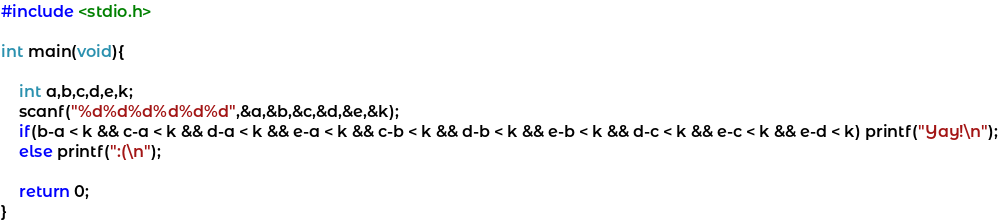Convert code to text. <code><loc_0><loc_0><loc_500><loc_500><_C_>#include <stdio.h>

int main(void){

	int a,b,c,d,e,k;
	scanf("%d%d%d%d%d%d",&a,&b,&c,&d,&e,&k);
	if(b-a < k && c-a < k && d-a < k && e-a < k && c-b < k && d-b < k && e-b < k && d-c < k && e-c < k && e-d < k) printf("Yay!\n");
	else printf(":(\n");	

	return 0;
}</code> 